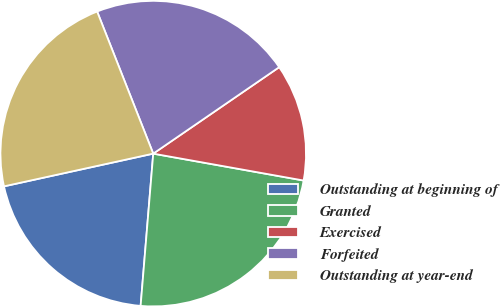Convert chart to OTSL. <chart><loc_0><loc_0><loc_500><loc_500><pie_chart><fcel>Outstanding at beginning of<fcel>Granted<fcel>Exercised<fcel>Forfeited<fcel>Outstanding at year-end<nl><fcel>20.25%<fcel>23.5%<fcel>12.39%<fcel>21.41%<fcel>22.45%<nl></chart> 